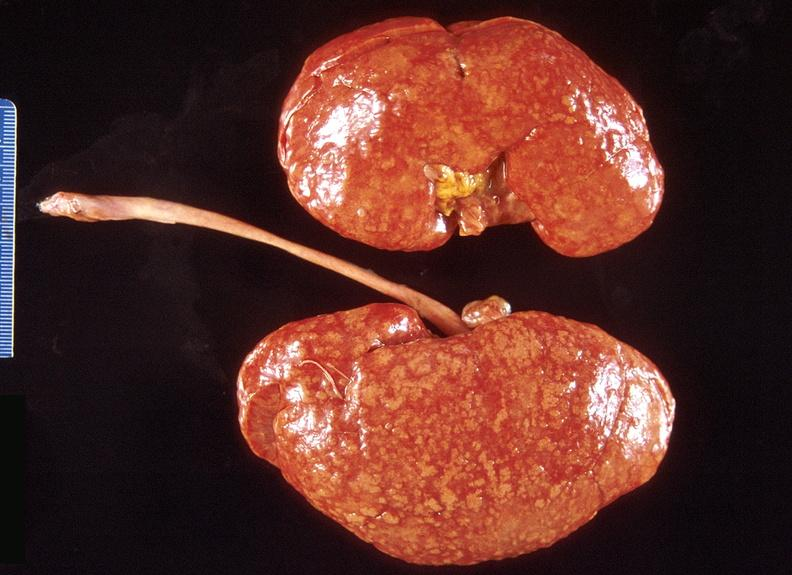does hypopharynx show kidney, obliterative endarteritis - sclerodema?
Answer the question using a single word or phrase. No 